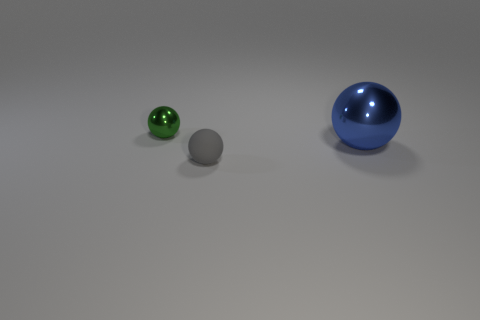What is the color of the other matte sphere that is the same size as the green ball?
Your answer should be compact. Gray. Is there another small metal object that has the same shape as the blue object?
Give a very brief answer. Yes. Are there fewer gray matte things than small green matte cylinders?
Ensure brevity in your answer.  No. The small ball behind the large blue object is what color?
Give a very brief answer. Green. Are the large blue ball and the small object that is to the left of the small matte sphere made of the same material?
Provide a succinct answer. Yes. How many things are the same size as the green sphere?
Your response must be concise. 1. Is the number of tiny objects behind the gray ball less than the number of balls?
Your response must be concise. Yes. There is a matte thing; what number of tiny balls are behind it?
Your response must be concise. 1. How big is the metal thing right of the tiny sphere that is right of the small sphere behind the big sphere?
Provide a succinct answer. Large. There is a blue metal object; does it have the same shape as the object behind the large ball?
Keep it short and to the point. Yes. 